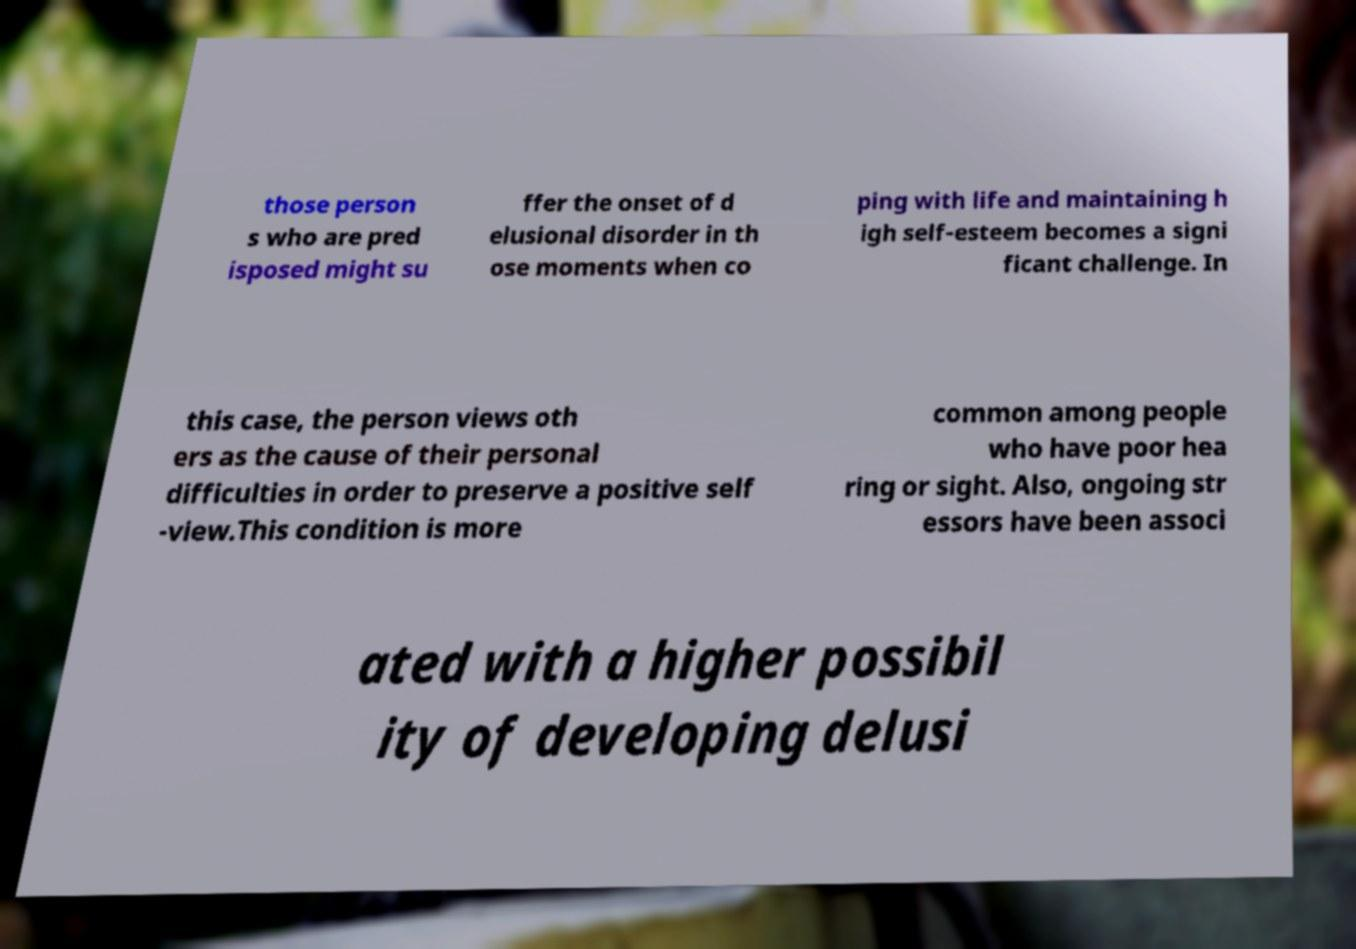Please identify and transcribe the text found in this image. those person s who are pred isposed might su ffer the onset of d elusional disorder in th ose moments when co ping with life and maintaining h igh self-esteem becomes a signi ficant challenge. In this case, the person views oth ers as the cause of their personal difficulties in order to preserve a positive self -view.This condition is more common among people who have poor hea ring or sight. Also, ongoing str essors have been associ ated with a higher possibil ity of developing delusi 